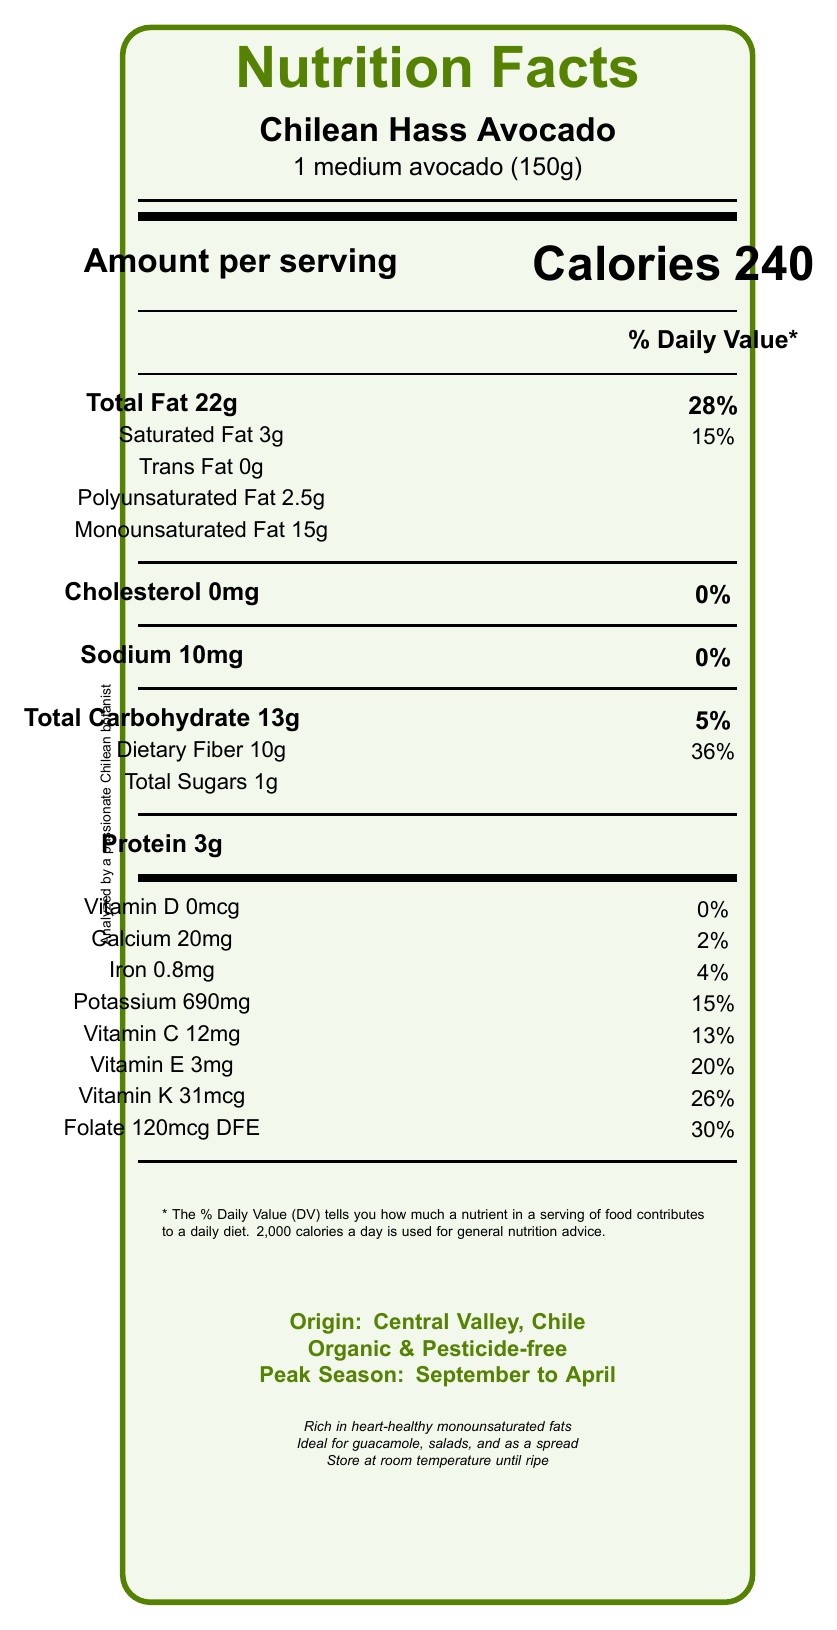what is the serving size for Chilean Hass Avocado? The serving size is directly mentioned in the Nutrition Facts section at the top of the document.
Answer: 1 medium avocado (150g) how many calories are in one serving of Chilean Hass Avocado? According to the Nutrition Facts, one serving contains 240 calories.
Answer: 240 what percentage of Daily Value is contributed by the total fat in one serving? The percentage of Daily Value for total fat is stated as 28% on the document.
Answer: 28% what is the amount of monounsaturated fat in a serving? The amount of monounsaturated fat is specified as 15g in the fat breakdown section.
Answer: 15g what is the dietary fiber content in one serving and its Daily Value percentage? The dietary fiber content is 10g and the Daily Value percentage is 36%.
Answer: 10g, 36% which of the following nutrients does not provide any Daily Value percentage? A. Vitamin C B. Sodium C. Iron D. Cholesterol Cholesterol is listed with 0% Daily Value in the document.
Answer: D. Cholesterol what is the main origin of Chilean Hass Avocado? A. Southern Chile B. Central Valley, Chile C. Coastal regions D. Northern Chile The origin is listed as Central Valley, Chile, in the additional information section.
Answer: B. Central Valley, Chile is the Chilean Hass Avocado good for heart health? The document mentions that it is rich in oleic acid, which may help reduce LDL cholesterol, indicating its heart-health benefits.
Answer: Yes what are the main culinary uses for Chilean Hass Avocado? These culinary uses are highlighted in the additional information section of the document.
Answer: Guacamole, salads, and as a spread on whole grain toast summarize the nutrition facts and additional info about Chilean Hass Avocado from the document. The summary includes key details about the nutritional content, health benefits, origin, and culinary uses provided in the document.
Answer: The document provides a detailed nutritional analysis of Chilean Hass Avocado, indicating it contains 240 calories per medium avocado (150g), with 22g of total fat, including 15g of monounsaturated fats, making it heart-healthy. It also includes significant dietary fiber (10g), no trans fat, and essential vitamins like Vitamin C, Vitamin E, Vitamin K, and folate. It originates from Central Valley, Chile, grown organically and is ideal for guacamole, salads, and as a spread. can you determine the exact cultivation method of Chilean Hass Avocado from the document? The document specifies that the avocados are cultivated organically, pesticide-free, using water-efficient drip irrigation systems.
Answer: Yes what is the cholesterol content in one serving of Chilean Hass Avocado? The cholesterol content is listed as 0mg in the Nutrition Facts section.
Answer: 0mg is the Chilean Hass Avocado a good source of vitamin D? The document shows 0mcg of Vitamin D per serving, with 0% Daily Value.
Answer: No which nutrient has the highest Daily Value percentage? A. Vitamin K B. Dietary Fiber C. Folate D. Monounsaturated Fat Dietary fiber has the highest Daily Value percentage of 36%.
Answer: B. Dietary Fiber what are the storage tips for Chilean Hass Avocado? The storage tips are included in the additional information section of the document.
Answer: Store at room temperature until ripe, then refrigerate for up to 5 days what is the main nutritional feature that makes Chilean Hass Avocado higher in heart-healthy benefits compared to Fuerte variety? The document specifically mentions that Chilean Hass Avocado is higher in monounsaturated fats compared to the Fuerte variety.
Answer: Higher in monounsaturated fats what is the total carbohydrate content in Chilean Hass Avocado, and what percentage of Daily Value does it represent? The total carbohydrate content is 13g, contributing to 5% of the Daily Value.
Answer: 13g, 5% what is the total amount of sugars present in one serving of Chilean Hass Avocado? The total sugars are listed as 1g in the Nutrition Facts section.
Answer: 1g does the document provide any information on vitamin A content in Chilean Hass Avocado? There is no information on vitamin A content provided in the document.
Answer: No 